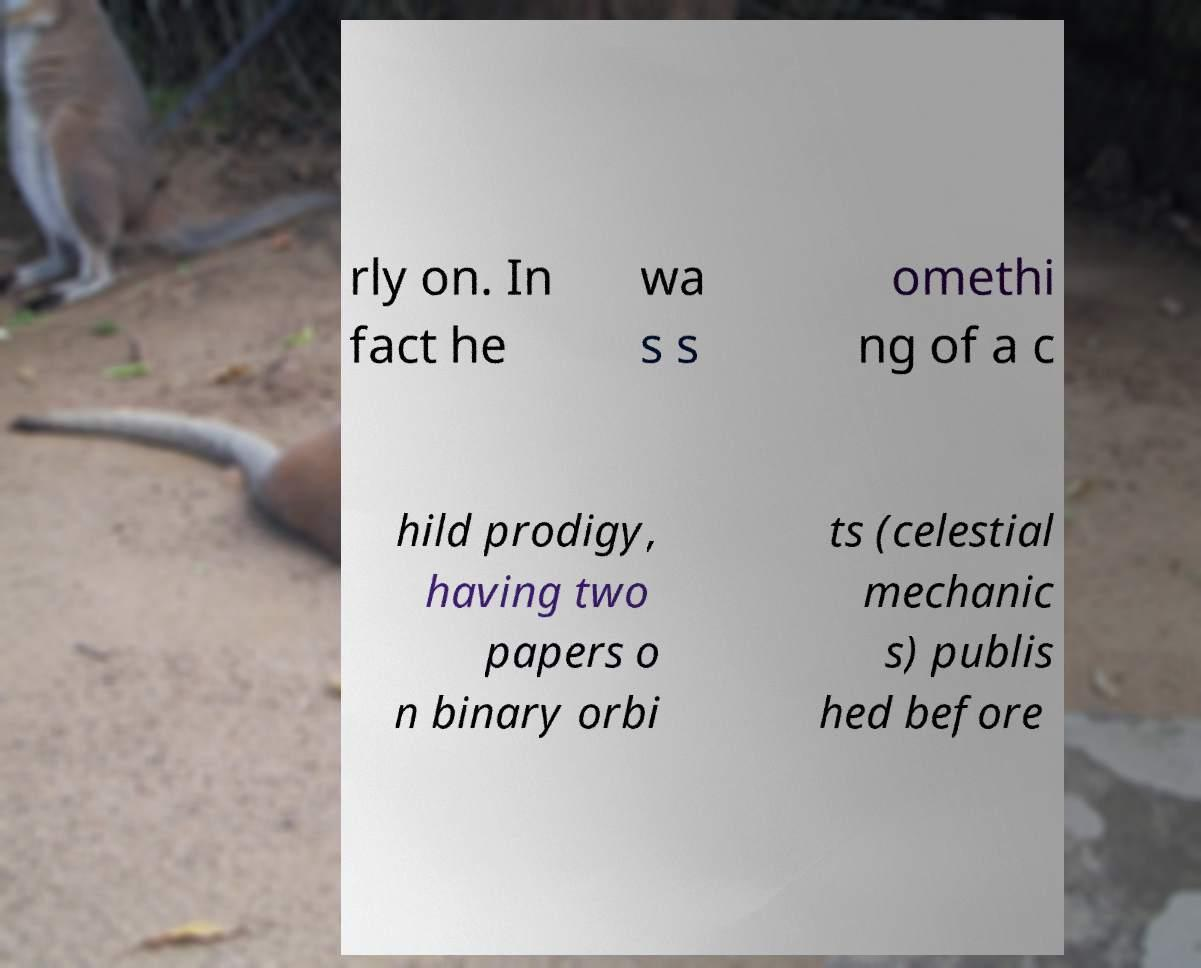What messages or text are displayed in this image? I need them in a readable, typed format. rly on. In fact he wa s s omethi ng of a c hild prodigy, having two papers o n binary orbi ts (celestial mechanic s) publis hed before 